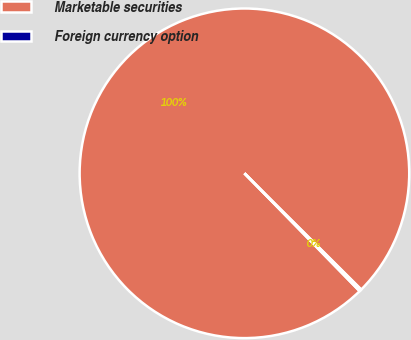Convert chart to OTSL. <chart><loc_0><loc_0><loc_500><loc_500><pie_chart><fcel>Marketable securities<fcel>Foreign currency option<nl><fcel>99.78%<fcel>0.22%<nl></chart> 